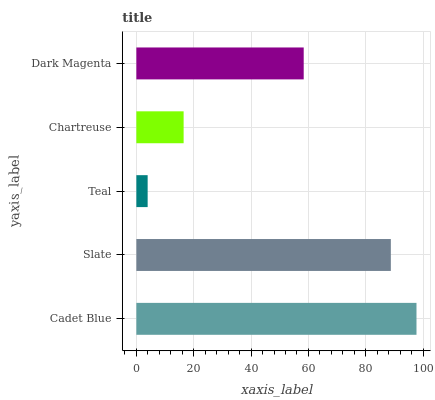Is Teal the minimum?
Answer yes or no. Yes. Is Cadet Blue the maximum?
Answer yes or no. Yes. Is Slate the minimum?
Answer yes or no. No. Is Slate the maximum?
Answer yes or no. No. Is Cadet Blue greater than Slate?
Answer yes or no. Yes. Is Slate less than Cadet Blue?
Answer yes or no. Yes. Is Slate greater than Cadet Blue?
Answer yes or no. No. Is Cadet Blue less than Slate?
Answer yes or no. No. Is Dark Magenta the high median?
Answer yes or no. Yes. Is Dark Magenta the low median?
Answer yes or no. Yes. Is Teal the high median?
Answer yes or no. No. Is Teal the low median?
Answer yes or no. No. 